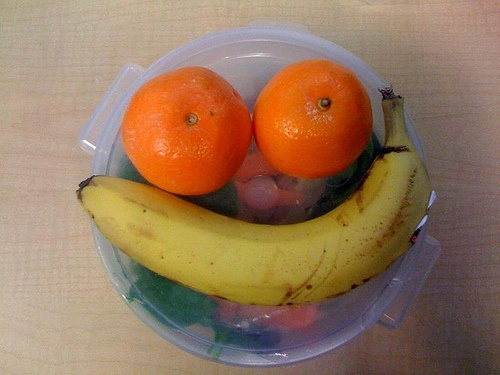Describe the objects in this image and their specific colors. I can see bowl in tan, red, gray, darkgray, and olive tones, orange in tan, red, and brown tones, and orange in tan, red, brown, and maroon tones in this image. 